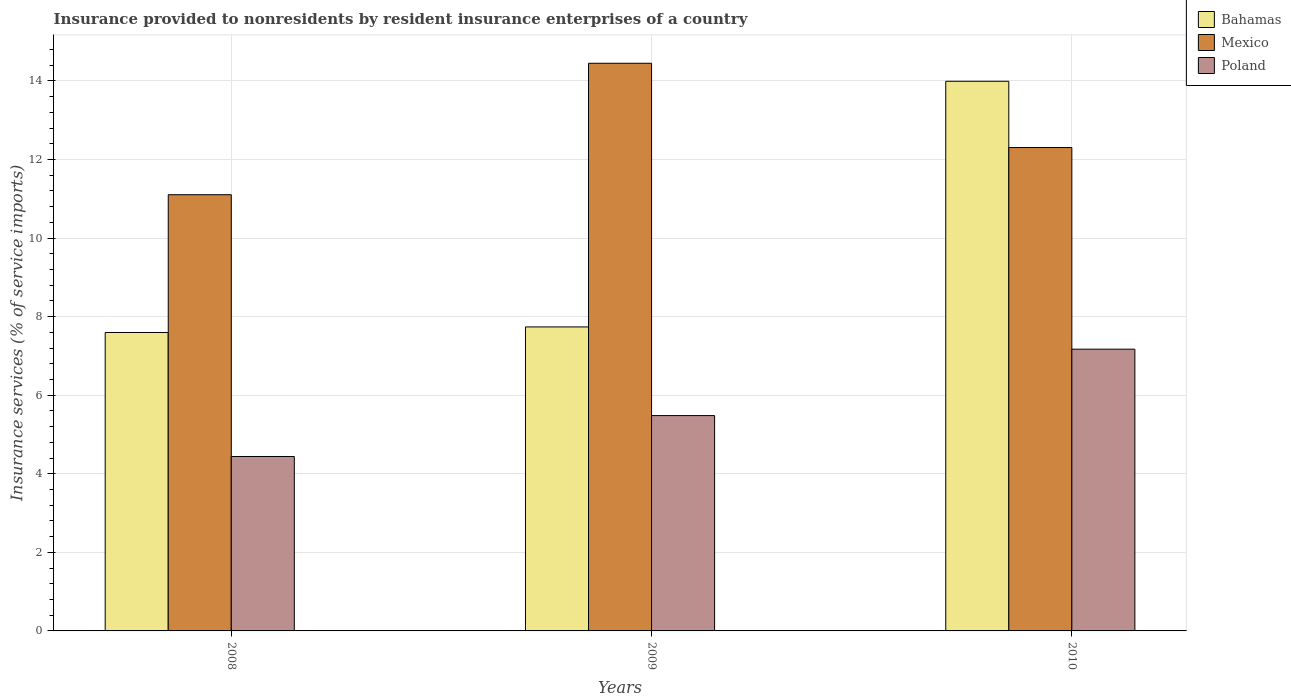Are the number of bars per tick equal to the number of legend labels?
Your answer should be very brief. Yes. How many bars are there on the 3rd tick from the right?
Ensure brevity in your answer.  3. What is the insurance provided to nonresidents in Bahamas in 2010?
Your answer should be compact. 13.99. Across all years, what is the maximum insurance provided to nonresidents in Mexico?
Your response must be concise. 14.45. Across all years, what is the minimum insurance provided to nonresidents in Poland?
Offer a terse response. 4.44. In which year was the insurance provided to nonresidents in Bahamas maximum?
Offer a very short reply. 2010. What is the total insurance provided to nonresidents in Bahamas in the graph?
Give a very brief answer. 29.33. What is the difference between the insurance provided to nonresidents in Mexico in 2008 and that in 2010?
Offer a very short reply. -1.2. What is the difference between the insurance provided to nonresidents in Poland in 2008 and the insurance provided to nonresidents in Bahamas in 2009?
Offer a terse response. -3.3. What is the average insurance provided to nonresidents in Bahamas per year?
Offer a terse response. 9.78. In the year 2008, what is the difference between the insurance provided to nonresidents in Mexico and insurance provided to nonresidents in Poland?
Your answer should be very brief. 6.66. In how many years, is the insurance provided to nonresidents in Poland greater than 5.2 %?
Offer a terse response. 2. What is the ratio of the insurance provided to nonresidents in Bahamas in 2008 to that in 2009?
Your response must be concise. 0.98. Is the insurance provided to nonresidents in Mexico in 2008 less than that in 2009?
Offer a terse response. Yes. What is the difference between the highest and the second highest insurance provided to nonresidents in Mexico?
Keep it short and to the point. 2.15. What is the difference between the highest and the lowest insurance provided to nonresidents in Poland?
Your answer should be compact. 2.73. In how many years, is the insurance provided to nonresidents in Bahamas greater than the average insurance provided to nonresidents in Bahamas taken over all years?
Ensure brevity in your answer.  1. What does the 3rd bar from the left in 2009 represents?
Your response must be concise. Poland. What does the 1st bar from the right in 2010 represents?
Your answer should be very brief. Poland. Is it the case that in every year, the sum of the insurance provided to nonresidents in Bahamas and insurance provided to nonresidents in Mexico is greater than the insurance provided to nonresidents in Poland?
Make the answer very short. Yes. How many bars are there?
Offer a terse response. 9. What is the difference between two consecutive major ticks on the Y-axis?
Keep it short and to the point. 2. Are the values on the major ticks of Y-axis written in scientific E-notation?
Ensure brevity in your answer.  No. Does the graph contain any zero values?
Offer a terse response. No. What is the title of the graph?
Offer a very short reply. Insurance provided to nonresidents by resident insurance enterprises of a country. Does "Guyana" appear as one of the legend labels in the graph?
Offer a terse response. No. What is the label or title of the X-axis?
Your response must be concise. Years. What is the label or title of the Y-axis?
Keep it short and to the point. Insurance services (% of service imports). What is the Insurance services (% of service imports) of Bahamas in 2008?
Give a very brief answer. 7.6. What is the Insurance services (% of service imports) in Mexico in 2008?
Ensure brevity in your answer.  11.1. What is the Insurance services (% of service imports) of Poland in 2008?
Provide a short and direct response. 4.44. What is the Insurance services (% of service imports) in Bahamas in 2009?
Provide a succinct answer. 7.74. What is the Insurance services (% of service imports) of Mexico in 2009?
Provide a succinct answer. 14.45. What is the Insurance services (% of service imports) in Poland in 2009?
Your answer should be compact. 5.48. What is the Insurance services (% of service imports) of Bahamas in 2010?
Keep it short and to the point. 13.99. What is the Insurance services (% of service imports) in Mexico in 2010?
Make the answer very short. 12.3. What is the Insurance services (% of service imports) in Poland in 2010?
Offer a terse response. 7.17. Across all years, what is the maximum Insurance services (% of service imports) in Bahamas?
Make the answer very short. 13.99. Across all years, what is the maximum Insurance services (% of service imports) in Mexico?
Keep it short and to the point. 14.45. Across all years, what is the maximum Insurance services (% of service imports) of Poland?
Your answer should be very brief. 7.17. Across all years, what is the minimum Insurance services (% of service imports) in Bahamas?
Your answer should be very brief. 7.6. Across all years, what is the minimum Insurance services (% of service imports) in Mexico?
Provide a short and direct response. 11.1. Across all years, what is the minimum Insurance services (% of service imports) in Poland?
Keep it short and to the point. 4.44. What is the total Insurance services (% of service imports) in Bahamas in the graph?
Your response must be concise. 29.33. What is the total Insurance services (% of service imports) in Mexico in the graph?
Ensure brevity in your answer.  37.86. What is the total Insurance services (% of service imports) of Poland in the graph?
Give a very brief answer. 17.09. What is the difference between the Insurance services (% of service imports) in Bahamas in 2008 and that in 2009?
Provide a succinct answer. -0.14. What is the difference between the Insurance services (% of service imports) of Mexico in 2008 and that in 2009?
Keep it short and to the point. -3.35. What is the difference between the Insurance services (% of service imports) in Poland in 2008 and that in 2009?
Provide a short and direct response. -1.04. What is the difference between the Insurance services (% of service imports) of Bahamas in 2008 and that in 2010?
Provide a succinct answer. -6.39. What is the difference between the Insurance services (% of service imports) in Mexico in 2008 and that in 2010?
Give a very brief answer. -1.2. What is the difference between the Insurance services (% of service imports) in Poland in 2008 and that in 2010?
Ensure brevity in your answer.  -2.73. What is the difference between the Insurance services (% of service imports) in Bahamas in 2009 and that in 2010?
Your answer should be very brief. -6.25. What is the difference between the Insurance services (% of service imports) of Mexico in 2009 and that in 2010?
Give a very brief answer. 2.15. What is the difference between the Insurance services (% of service imports) of Poland in 2009 and that in 2010?
Keep it short and to the point. -1.69. What is the difference between the Insurance services (% of service imports) of Bahamas in 2008 and the Insurance services (% of service imports) of Mexico in 2009?
Make the answer very short. -6.85. What is the difference between the Insurance services (% of service imports) of Bahamas in 2008 and the Insurance services (% of service imports) of Poland in 2009?
Offer a very short reply. 2.12. What is the difference between the Insurance services (% of service imports) of Mexico in 2008 and the Insurance services (% of service imports) of Poland in 2009?
Offer a very short reply. 5.62. What is the difference between the Insurance services (% of service imports) in Bahamas in 2008 and the Insurance services (% of service imports) in Mexico in 2010?
Your response must be concise. -4.71. What is the difference between the Insurance services (% of service imports) of Bahamas in 2008 and the Insurance services (% of service imports) of Poland in 2010?
Offer a terse response. 0.42. What is the difference between the Insurance services (% of service imports) of Mexico in 2008 and the Insurance services (% of service imports) of Poland in 2010?
Give a very brief answer. 3.93. What is the difference between the Insurance services (% of service imports) of Bahamas in 2009 and the Insurance services (% of service imports) of Mexico in 2010?
Your answer should be compact. -4.57. What is the difference between the Insurance services (% of service imports) in Bahamas in 2009 and the Insurance services (% of service imports) in Poland in 2010?
Provide a succinct answer. 0.57. What is the difference between the Insurance services (% of service imports) of Mexico in 2009 and the Insurance services (% of service imports) of Poland in 2010?
Keep it short and to the point. 7.28. What is the average Insurance services (% of service imports) of Bahamas per year?
Provide a succinct answer. 9.78. What is the average Insurance services (% of service imports) in Mexico per year?
Your answer should be very brief. 12.62. What is the average Insurance services (% of service imports) of Poland per year?
Your answer should be compact. 5.7. In the year 2008, what is the difference between the Insurance services (% of service imports) of Bahamas and Insurance services (% of service imports) of Mexico?
Make the answer very short. -3.51. In the year 2008, what is the difference between the Insurance services (% of service imports) in Bahamas and Insurance services (% of service imports) in Poland?
Offer a terse response. 3.16. In the year 2008, what is the difference between the Insurance services (% of service imports) in Mexico and Insurance services (% of service imports) in Poland?
Your response must be concise. 6.66. In the year 2009, what is the difference between the Insurance services (% of service imports) of Bahamas and Insurance services (% of service imports) of Mexico?
Provide a succinct answer. -6.71. In the year 2009, what is the difference between the Insurance services (% of service imports) of Bahamas and Insurance services (% of service imports) of Poland?
Keep it short and to the point. 2.26. In the year 2009, what is the difference between the Insurance services (% of service imports) of Mexico and Insurance services (% of service imports) of Poland?
Your response must be concise. 8.97. In the year 2010, what is the difference between the Insurance services (% of service imports) in Bahamas and Insurance services (% of service imports) in Mexico?
Make the answer very short. 1.69. In the year 2010, what is the difference between the Insurance services (% of service imports) in Bahamas and Insurance services (% of service imports) in Poland?
Offer a very short reply. 6.82. In the year 2010, what is the difference between the Insurance services (% of service imports) of Mexico and Insurance services (% of service imports) of Poland?
Offer a very short reply. 5.13. What is the ratio of the Insurance services (% of service imports) in Bahamas in 2008 to that in 2009?
Provide a short and direct response. 0.98. What is the ratio of the Insurance services (% of service imports) of Mexico in 2008 to that in 2009?
Your answer should be very brief. 0.77. What is the ratio of the Insurance services (% of service imports) in Poland in 2008 to that in 2009?
Ensure brevity in your answer.  0.81. What is the ratio of the Insurance services (% of service imports) of Bahamas in 2008 to that in 2010?
Provide a short and direct response. 0.54. What is the ratio of the Insurance services (% of service imports) in Mexico in 2008 to that in 2010?
Give a very brief answer. 0.9. What is the ratio of the Insurance services (% of service imports) of Poland in 2008 to that in 2010?
Your answer should be very brief. 0.62. What is the ratio of the Insurance services (% of service imports) of Bahamas in 2009 to that in 2010?
Provide a short and direct response. 0.55. What is the ratio of the Insurance services (% of service imports) in Mexico in 2009 to that in 2010?
Make the answer very short. 1.17. What is the ratio of the Insurance services (% of service imports) in Poland in 2009 to that in 2010?
Your answer should be very brief. 0.76. What is the difference between the highest and the second highest Insurance services (% of service imports) in Bahamas?
Keep it short and to the point. 6.25. What is the difference between the highest and the second highest Insurance services (% of service imports) in Mexico?
Your answer should be compact. 2.15. What is the difference between the highest and the second highest Insurance services (% of service imports) of Poland?
Give a very brief answer. 1.69. What is the difference between the highest and the lowest Insurance services (% of service imports) of Bahamas?
Offer a terse response. 6.39. What is the difference between the highest and the lowest Insurance services (% of service imports) in Mexico?
Make the answer very short. 3.35. What is the difference between the highest and the lowest Insurance services (% of service imports) of Poland?
Make the answer very short. 2.73. 